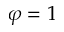<formula> <loc_0><loc_0><loc_500><loc_500>\varphi = 1</formula> 